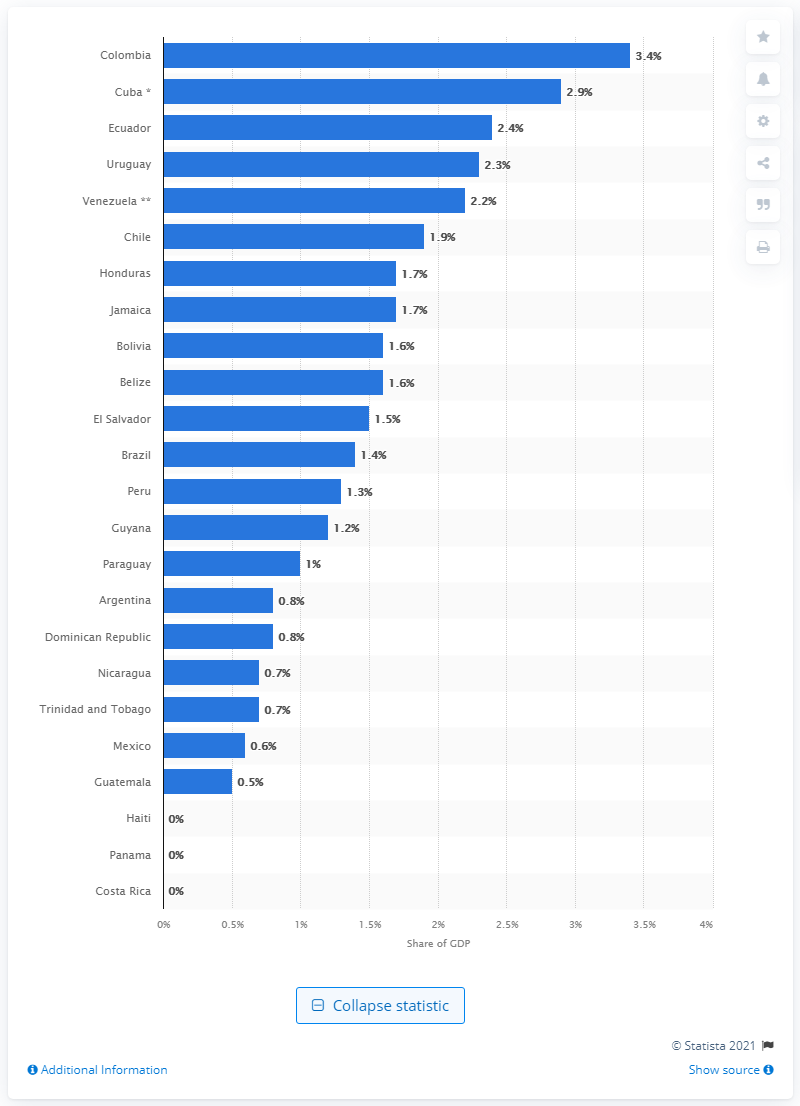List a handful of essential elements in this visual. According to data from 2020, military expenditure represented approximately 3.4% of Colombia's Gross Domestic Product. 